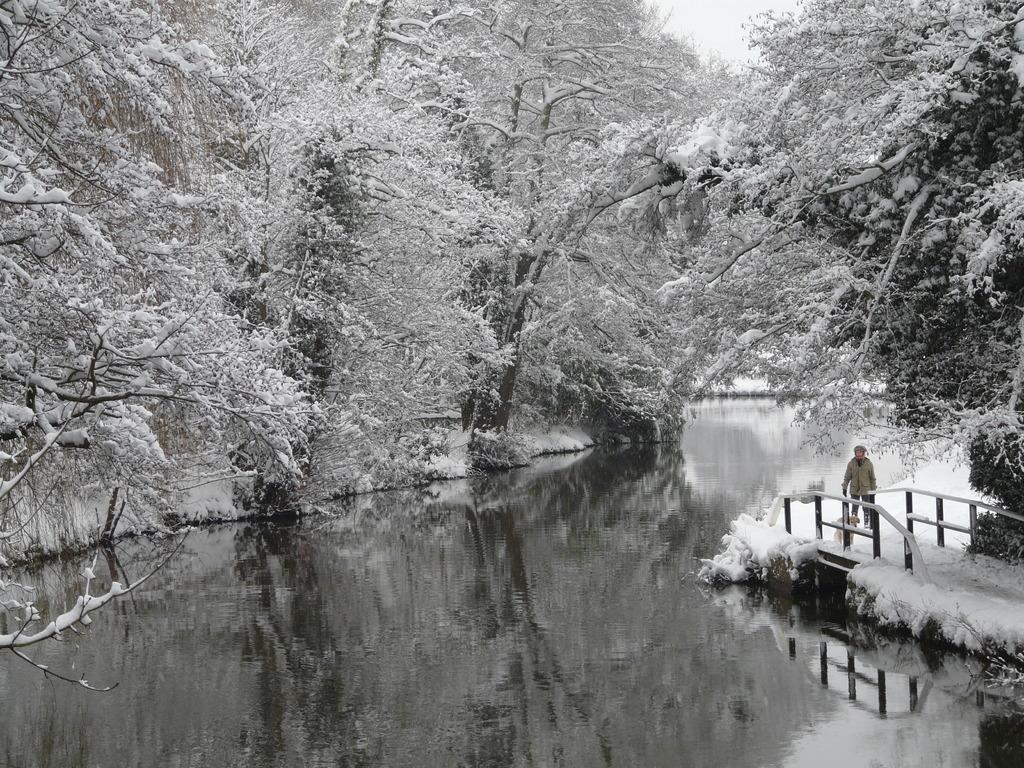Could you give a brief overview of what you see in this image? In this image we can see a person standing on the bridge which is covered with the snow. We can also see the trees which are fully covered with the snow. At the bottom we can see the water. Sky is also visible in this image. 